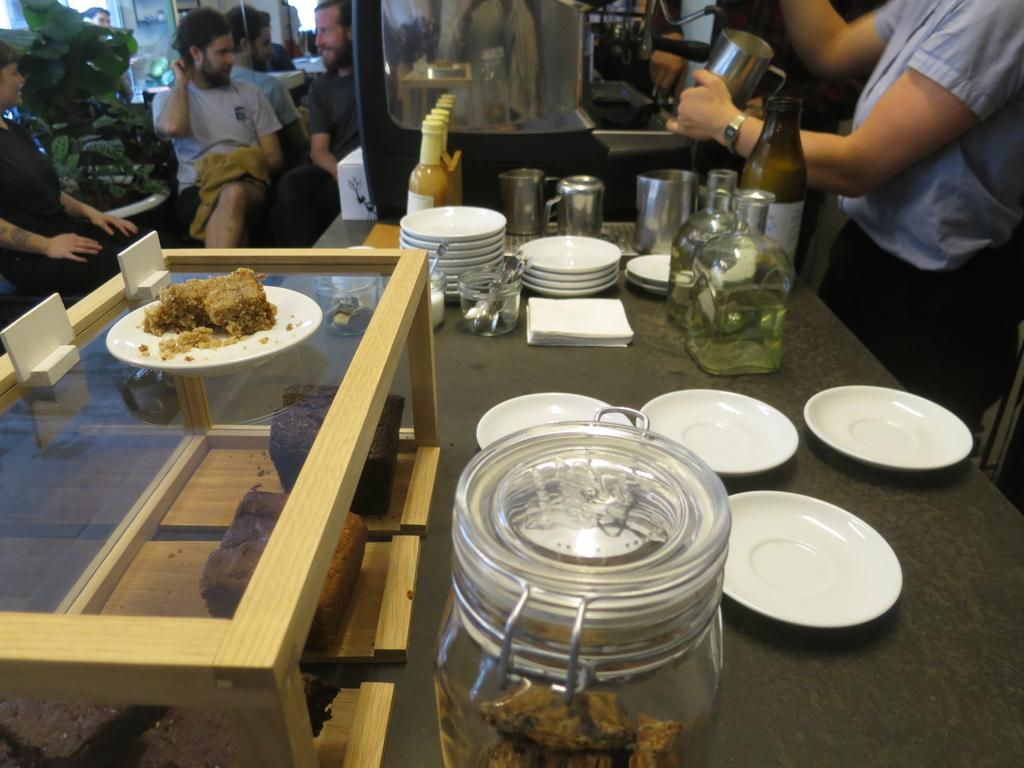What is the main piece of furniture in the image? There is a table in the image. What items can be seen on the table? The table has saucers, a jar, bottles, and cups on it. Can you describe the background of the image? There are people sitting and plants in the background of the image. What type of ink is being used by the person sitting in the background of the image? There is no indication in the image that anyone is using ink, as the focus is on the table and its contents. 